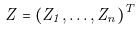<formula> <loc_0><loc_0><loc_500><loc_500>Z = ( Z _ { 1 } , \dots , Z _ { n } ) ^ { T }</formula> 